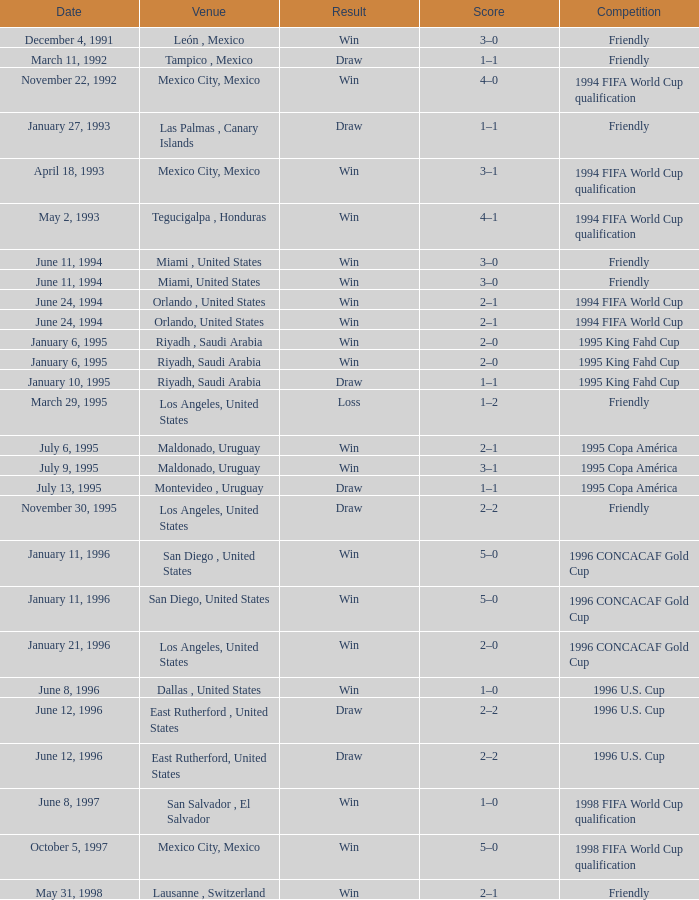What is Result, when Date is "June 11, 1994", and when Venue is "Miami, United States"? Win, Win. 